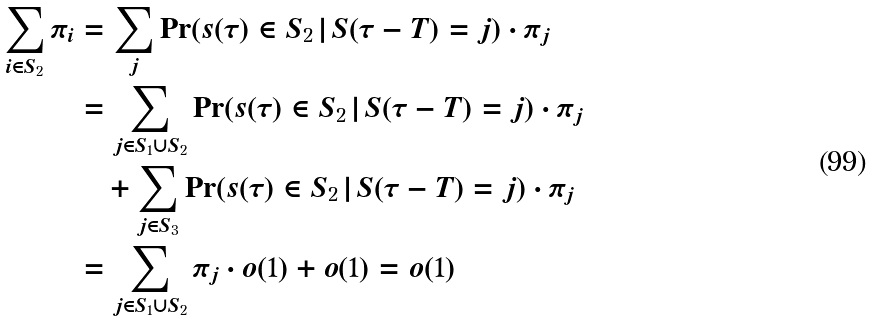<formula> <loc_0><loc_0><loc_500><loc_500>\sum _ { i \in S _ { 2 } } \pi _ { i } & = \sum _ { j } \Pr ( s ( \tau ) \in S _ { 2 } \, | \, S ( \tau - T ) = j ) \cdot \pi _ { j } \\ & = \sum _ { j \in S _ { 1 } \cup S _ { 2 } } \Pr ( s ( \tau ) \in S _ { 2 } \, | \, S ( \tau - T ) = j ) \cdot \pi _ { j } \\ & \quad + \sum _ { j \in S _ { 3 } } \Pr ( s ( \tau ) \in S _ { 2 } \, | \, S ( \tau - T ) = j ) \cdot \pi _ { j } \\ & = \sum _ { j \in S _ { 1 } \cup S _ { 2 } } \pi _ { j } \cdot o ( 1 ) + o ( 1 ) = o ( 1 )</formula> 